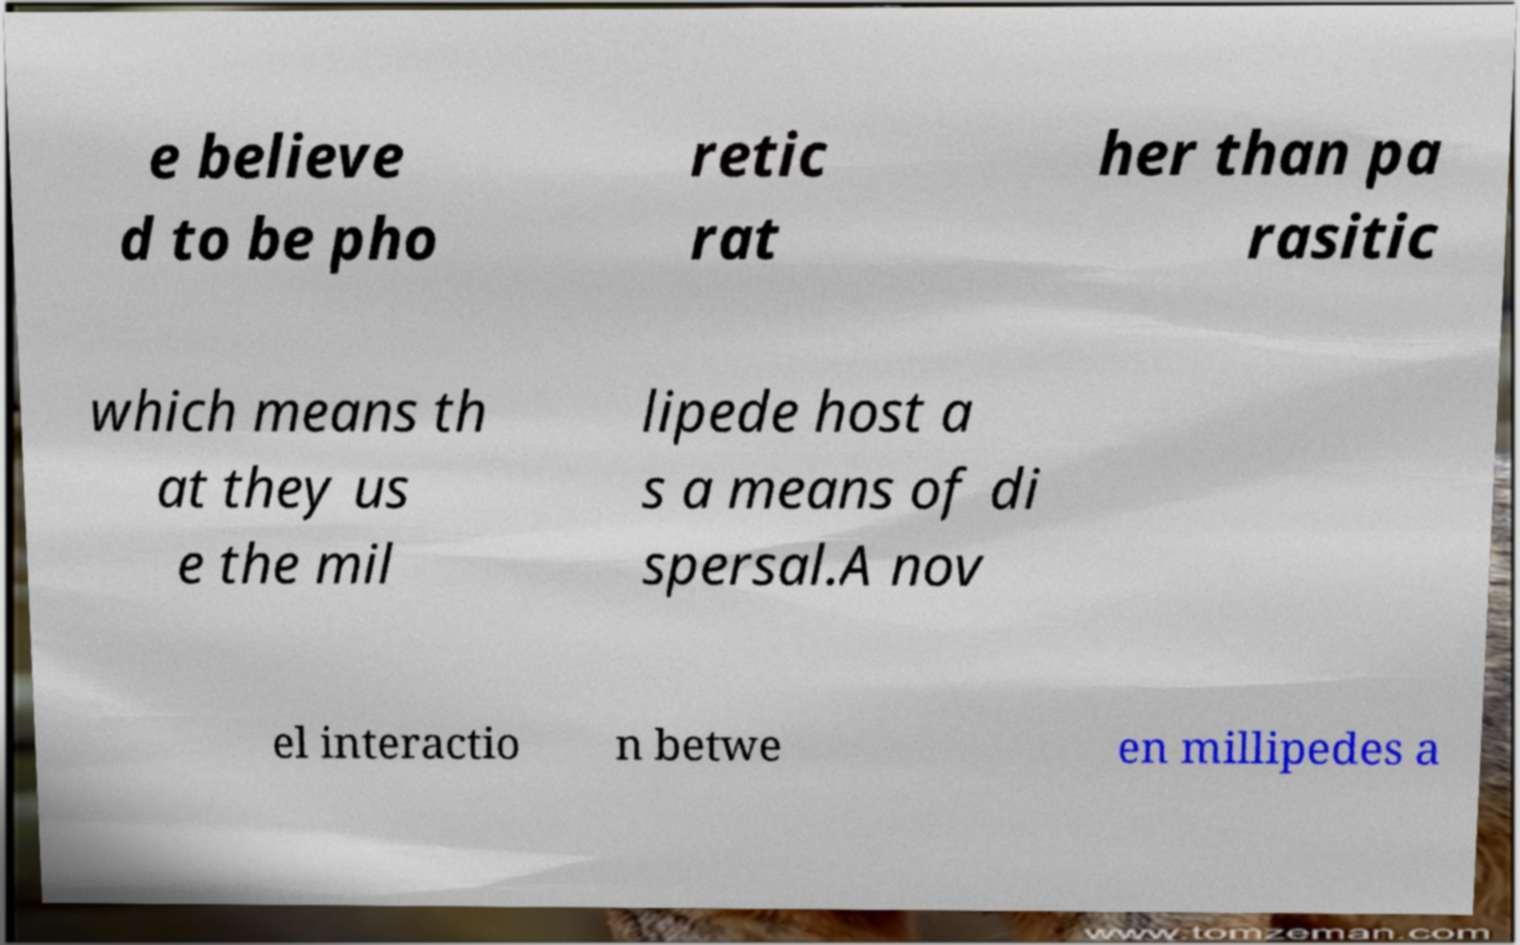What messages or text are displayed in this image? I need them in a readable, typed format. e believe d to be pho retic rat her than pa rasitic which means th at they us e the mil lipede host a s a means of di spersal.A nov el interactio n betwe en millipedes a 